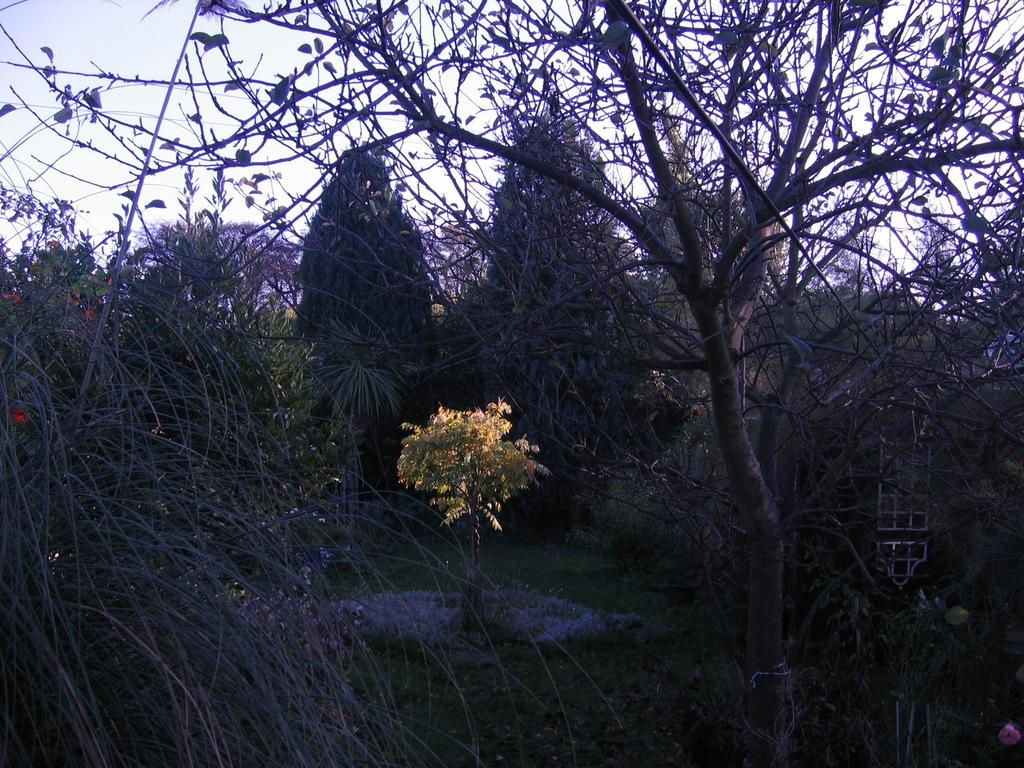What type of vegetation can be seen in the image? There are trees, plants, grass, and flowers in the image. What else is present in the image besides vegetation? There are objects in the image. What can be seen in the background of the image? The sky is visible in the background of the image. Can you see a pig walking on its toes in the image? There is no pig or any indication of walking on toes in the image. What type of sand can be seen in the image? There is no sand present in the image; it features vegetation and objects. 